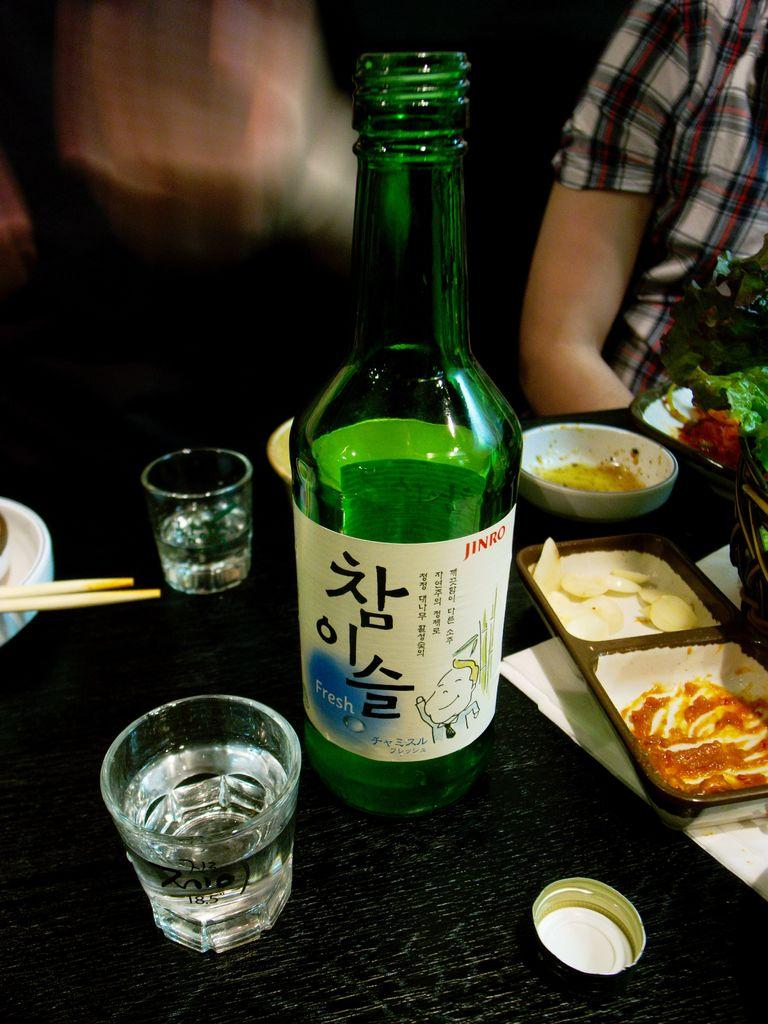<image>
Render a clear and concise summary of the photo. a green bottle of Jinro Fresh with Korean letters on a restaurant table 